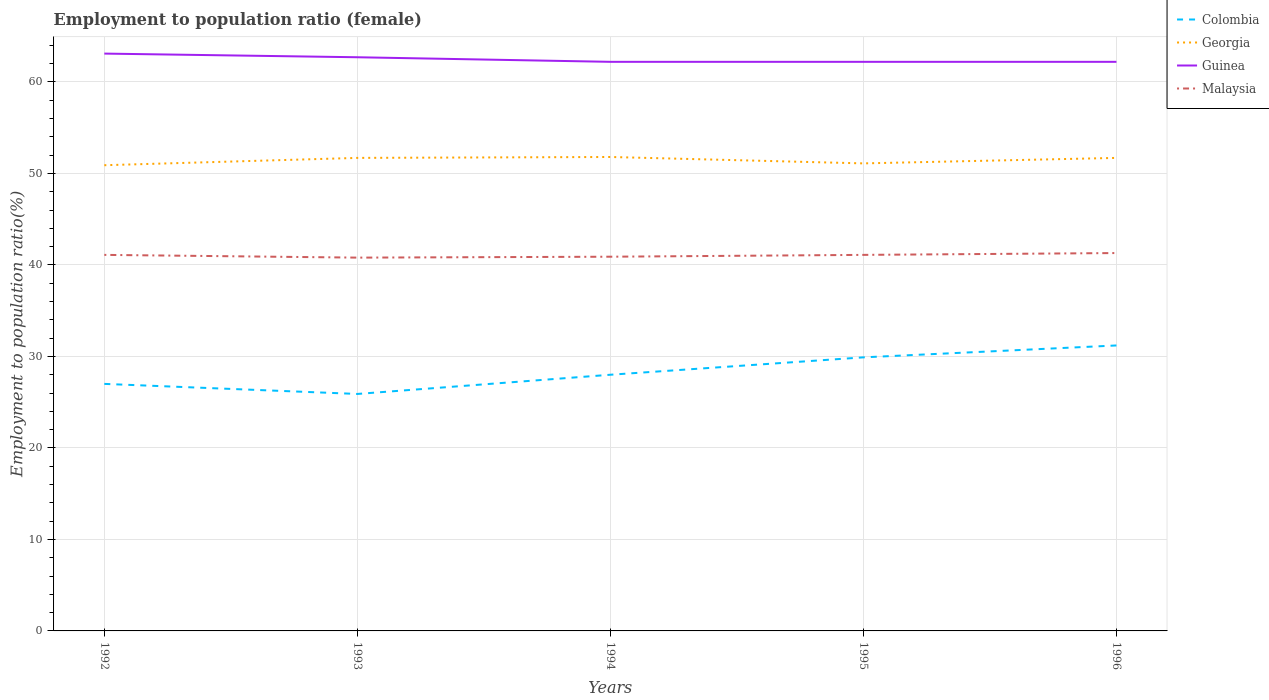How many different coloured lines are there?
Your answer should be very brief. 4. Does the line corresponding to Guinea intersect with the line corresponding to Georgia?
Ensure brevity in your answer.  No. Across all years, what is the maximum employment to population ratio in Malaysia?
Make the answer very short. 40.8. What is the difference between the highest and the second highest employment to population ratio in Georgia?
Make the answer very short. 0.9. What is the difference between the highest and the lowest employment to population ratio in Malaysia?
Provide a short and direct response. 3. Is the employment to population ratio in Georgia strictly greater than the employment to population ratio in Guinea over the years?
Offer a very short reply. Yes. How many lines are there?
Offer a very short reply. 4. Does the graph contain any zero values?
Ensure brevity in your answer.  No. How are the legend labels stacked?
Offer a terse response. Vertical. What is the title of the graph?
Your answer should be compact. Employment to population ratio (female). Does "Kuwait" appear as one of the legend labels in the graph?
Make the answer very short. No. What is the label or title of the X-axis?
Provide a succinct answer. Years. What is the label or title of the Y-axis?
Provide a short and direct response. Employment to population ratio(%). What is the Employment to population ratio(%) in Colombia in 1992?
Provide a succinct answer. 27. What is the Employment to population ratio(%) in Georgia in 1992?
Give a very brief answer. 50.9. What is the Employment to population ratio(%) of Guinea in 1992?
Give a very brief answer. 63.1. What is the Employment to population ratio(%) in Malaysia in 1992?
Provide a short and direct response. 41.1. What is the Employment to population ratio(%) of Colombia in 1993?
Your answer should be very brief. 25.9. What is the Employment to population ratio(%) in Georgia in 1993?
Your answer should be very brief. 51.7. What is the Employment to population ratio(%) in Guinea in 1993?
Give a very brief answer. 62.7. What is the Employment to population ratio(%) in Malaysia in 1993?
Ensure brevity in your answer.  40.8. What is the Employment to population ratio(%) in Colombia in 1994?
Your response must be concise. 28. What is the Employment to population ratio(%) in Georgia in 1994?
Your answer should be compact. 51.8. What is the Employment to population ratio(%) of Guinea in 1994?
Offer a terse response. 62.2. What is the Employment to population ratio(%) in Malaysia in 1994?
Your answer should be very brief. 40.9. What is the Employment to population ratio(%) of Colombia in 1995?
Make the answer very short. 29.9. What is the Employment to population ratio(%) in Georgia in 1995?
Offer a terse response. 51.1. What is the Employment to population ratio(%) of Guinea in 1995?
Provide a short and direct response. 62.2. What is the Employment to population ratio(%) in Malaysia in 1995?
Offer a terse response. 41.1. What is the Employment to population ratio(%) of Colombia in 1996?
Provide a succinct answer. 31.2. What is the Employment to population ratio(%) in Georgia in 1996?
Provide a short and direct response. 51.7. What is the Employment to population ratio(%) of Guinea in 1996?
Offer a terse response. 62.2. What is the Employment to population ratio(%) of Malaysia in 1996?
Provide a succinct answer. 41.3. Across all years, what is the maximum Employment to population ratio(%) of Colombia?
Offer a terse response. 31.2. Across all years, what is the maximum Employment to population ratio(%) in Georgia?
Ensure brevity in your answer.  51.8. Across all years, what is the maximum Employment to population ratio(%) of Guinea?
Provide a short and direct response. 63.1. Across all years, what is the maximum Employment to population ratio(%) in Malaysia?
Provide a short and direct response. 41.3. Across all years, what is the minimum Employment to population ratio(%) of Colombia?
Ensure brevity in your answer.  25.9. Across all years, what is the minimum Employment to population ratio(%) of Georgia?
Ensure brevity in your answer.  50.9. Across all years, what is the minimum Employment to population ratio(%) in Guinea?
Offer a terse response. 62.2. Across all years, what is the minimum Employment to population ratio(%) in Malaysia?
Give a very brief answer. 40.8. What is the total Employment to population ratio(%) of Colombia in the graph?
Your response must be concise. 142. What is the total Employment to population ratio(%) in Georgia in the graph?
Your answer should be compact. 257.2. What is the total Employment to population ratio(%) in Guinea in the graph?
Your response must be concise. 312.4. What is the total Employment to population ratio(%) of Malaysia in the graph?
Keep it short and to the point. 205.2. What is the difference between the Employment to population ratio(%) of Colombia in 1992 and that in 1993?
Your answer should be very brief. 1.1. What is the difference between the Employment to population ratio(%) in Georgia in 1992 and that in 1993?
Keep it short and to the point. -0.8. What is the difference between the Employment to population ratio(%) of Malaysia in 1992 and that in 1993?
Keep it short and to the point. 0.3. What is the difference between the Employment to population ratio(%) of Colombia in 1992 and that in 1994?
Provide a succinct answer. -1. What is the difference between the Employment to population ratio(%) of Georgia in 1992 and that in 1994?
Your response must be concise. -0.9. What is the difference between the Employment to population ratio(%) of Georgia in 1992 and that in 1995?
Ensure brevity in your answer.  -0.2. What is the difference between the Employment to population ratio(%) in Guinea in 1992 and that in 1995?
Offer a terse response. 0.9. What is the difference between the Employment to population ratio(%) in Georgia in 1992 and that in 1996?
Offer a terse response. -0.8. What is the difference between the Employment to population ratio(%) in Colombia in 1993 and that in 1994?
Your response must be concise. -2.1. What is the difference between the Employment to population ratio(%) in Guinea in 1993 and that in 1995?
Give a very brief answer. 0.5. What is the difference between the Employment to population ratio(%) in Malaysia in 1993 and that in 1995?
Provide a succinct answer. -0.3. What is the difference between the Employment to population ratio(%) of Colombia in 1994 and that in 1995?
Make the answer very short. -1.9. What is the difference between the Employment to population ratio(%) of Georgia in 1994 and that in 1995?
Offer a very short reply. 0.7. What is the difference between the Employment to population ratio(%) in Colombia in 1994 and that in 1996?
Offer a terse response. -3.2. What is the difference between the Employment to population ratio(%) in Georgia in 1994 and that in 1996?
Your response must be concise. 0.1. What is the difference between the Employment to population ratio(%) in Guinea in 1994 and that in 1996?
Give a very brief answer. 0. What is the difference between the Employment to population ratio(%) of Malaysia in 1994 and that in 1996?
Your answer should be very brief. -0.4. What is the difference between the Employment to population ratio(%) of Georgia in 1995 and that in 1996?
Your response must be concise. -0.6. What is the difference between the Employment to population ratio(%) in Malaysia in 1995 and that in 1996?
Give a very brief answer. -0.2. What is the difference between the Employment to population ratio(%) of Colombia in 1992 and the Employment to population ratio(%) of Georgia in 1993?
Offer a terse response. -24.7. What is the difference between the Employment to population ratio(%) of Colombia in 1992 and the Employment to population ratio(%) of Guinea in 1993?
Your answer should be compact. -35.7. What is the difference between the Employment to population ratio(%) of Colombia in 1992 and the Employment to population ratio(%) of Malaysia in 1993?
Ensure brevity in your answer.  -13.8. What is the difference between the Employment to population ratio(%) in Georgia in 1992 and the Employment to population ratio(%) in Guinea in 1993?
Your answer should be very brief. -11.8. What is the difference between the Employment to population ratio(%) in Guinea in 1992 and the Employment to population ratio(%) in Malaysia in 1993?
Your response must be concise. 22.3. What is the difference between the Employment to population ratio(%) in Colombia in 1992 and the Employment to population ratio(%) in Georgia in 1994?
Provide a short and direct response. -24.8. What is the difference between the Employment to population ratio(%) of Colombia in 1992 and the Employment to population ratio(%) of Guinea in 1994?
Provide a short and direct response. -35.2. What is the difference between the Employment to population ratio(%) in Colombia in 1992 and the Employment to population ratio(%) in Malaysia in 1994?
Give a very brief answer. -13.9. What is the difference between the Employment to population ratio(%) of Georgia in 1992 and the Employment to population ratio(%) of Guinea in 1994?
Offer a very short reply. -11.3. What is the difference between the Employment to population ratio(%) in Georgia in 1992 and the Employment to population ratio(%) in Malaysia in 1994?
Your answer should be compact. 10. What is the difference between the Employment to population ratio(%) in Guinea in 1992 and the Employment to population ratio(%) in Malaysia in 1994?
Your answer should be very brief. 22.2. What is the difference between the Employment to population ratio(%) in Colombia in 1992 and the Employment to population ratio(%) in Georgia in 1995?
Offer a terse response. -24.1. What is the difference between the Employment to population ratio(%) in Colombia in 1992 and the Employment to population ratio(%) in Guinea in 1995?
Offer a very short reply. -35.2. What is the difference between the Employment to population ratio(%) of Colombia in 1992 and the Employment to population ratio(%) of Malaysia in 1995?
Ensure brevity in your answer.  -14.1. What is the difference between the Employment to population ratio(%) of Georgia in 1992 and the Employment to population ratio(%) of Guinea in 1995?
Offer a very short reply. -11.3. What is the difference between the Employment to population ratio(%) of Georgia in 1992 and the Employment to population ratio(%) of Malaysia in 1995?
Keep it short and to the point. 9.8. What is the difference between the Employment to population ratio(%) of Guinea in 1992 and the Employment to population ratio(%) of Malaysia in 1995?
Make the answer very short. 22. What is the difference between the Employment to population ratio(%) in Colombia in 1992 and the Employment to population ratio(%) in Georgia in 1996?
Offer a terse response. -24.7. What is the difference between the Employment to population ratio(%) of Colombia in 1992 and the Employment to population ratio(%) of Guinea in 1996?
Give a very brief answer. -35.2. What is the difference between the Employment to population ratio(%) in Colombia in 1992 and the Employment to population ratio(%) in Malaysia in 1996?
Your answer should be compact. -14.3. What is the difference between the Employment to population ratio(%) in Georgia in 1992 and the Employment to population ratio(%) in Guinea in 1996?
Provide a short and direct response. -11.3. What is the difference between the Employment to population ratio(%) of Guinea in 1992 and the Employment to population ratio(%) of Malaysia in 1996?
Your answer should be very brief. 21.8. What is the difference between the Employment to population ratio(%) in Colombia in 1993 and the Employment to population ratio(%) in Georgia in 1994?
Your answer should be compact. -25.9. What is the difference between the Employment to population ratio(%) in Colombia in 1993 and the Employment to population ratio(%) in Guinea in 1994?
Offer a terse response. -36.3. What is the difference between the Employment to population ratio(%) of Georgia in 1993 and the Employment to population ratio(%) of Malaysia in 1994?
Provide a short and direct response. 10.8. What is the difference between the Employment to population ratio(%) of Guinea in 1993 and the Employment to population ratio(%) of Malaysia in 1994?
Keep it short and to the point. 21.8. What is the difference between the Employment to population ratio(%) of Colombia in 1993 and the Employment to population ratio(%) of Georgia in 1995?
Your answer should be compact. -25.2. What is the difference between the Employment to population ratio(%) in Colombia in 1993 and the Employment to population ratio(%) in Guinea in 1995?
Ensure brevity in your answer.  -36.3. What is the difference between the Employment to population ratio(%) in Colombia in 1993 and the Employment to population ratio(%) in Malaysia in 1995?
Provide a short and direct response. -15.2. What is the difference between the Employment to population ratio(%) in Georgia in 1993 and the Employment to population ratio(%) in Guinea in 1995?
Offer a very short reply. -10.5. What is the difference between the Employment to population ratio(%) in Guinea in 1993 and the Employment to population ratio(%) in Malaysia in 1995?
Offer a terse response. 21.6. What is the difference between the Employment to population ratio(%) in Colombia in 1993 and the Employment to population ratio(%) in Georgia in 1996?
Your response must be concise. -25.8. What is the difference between the Employment to population ratio(%) of Colombia in 1993 and the Employment to population ratio(%) of Guinea in 1996?
Make the answer very short. -36.3. What is the difference between the Employment to population ratio(%) of Colombia in 1993 and the Employment to population ratio(%) of Malaysia in 1996?
Keep it short and to the point. -15.4. What is the difference between the Employment to population ratio(%) in Georgia in 1993 and the Employment to population ratio(%) in Guinea in 1996?
Give a very brief answer. -10.5. What is the difference between the Employment to population ratio(%) of Georgia in 1993 and the Employment to population ratio(%) of Malaysia in 1996?
Keep it short and to the point. 10.4. What is the difference between the Employment to population ratio(%) of Guinea in 1993 and the Employment to population ratio(%) of Malaysia in 1996?
Offer a terse response. 21.4. What is the difference between the Employment to population ratio(%) of Colombia in 1994 and the Employment to population ratio(%) of Georgia in 1995?
Keep it short and to the point. -23.1. What is the difference between the Employment to population ratio(%) of Colombia in 1994 and the Employment to population ratio(%) of Guinea in 1995?
Ensure brevity in your answer.  -34.2. What is the difference between the Employment to population ratio(%) of Georgia in 1994 and the Employment to population ratio(%) of Guinea in 1995?
Ensure brevity in your answer.  -10.4. What is the difference between the Employment to population ratio(%) of Georgia in 1994 and the Employment to population ratio(%) of Malaysia in 1995?
Your response must be concise. 10.7. What is the difference between the Employment to population ratio(%) in Guinea in 1994 and the Employment to population ratio(%) in Malaysia in 1995?
Give a very brief answer. 21.1. What is the difference between the Employment to population ratio(%) in Colombia in 1994 and the Employment to population ratio(%) in Georgia in 1996?
Offer a terse response. -23.7. What is the difference between the Employment to population ratio(%) in Colombia in 1994 and the Employment to population ratio(%) in Guinea in 1996?
Your answer should be very brief. -34.2. What is the difference between the Employment to population ratio(%) in Georgia in 1994 and the Employment to population ratio(%) in Guinea in 1996?
Ensure brevity in your answer.  -10.4. What is the difference between the Employment to population ratio(%) in Georgia in 1994 and the Employment to population ratio(%) in Malaysia in 1996?
Provide a short and direct response. 10.5. What is the difference between the Employment to population ratio(%) in Guinea in 1994 and the Employment to population ratio(%) in Malaysia in 1996?
Make the answer very short. 20.9. What is the difference between the Employment to population ratio(%) in Colombia in 1995 and the Employment to population ratio(%) in Georgia in 1996?
Make the answer very short. -21.8. What is the difference between the Employment to population ratio(%) in Colombia in 1995 and the Employment to population ratio(%) in Guinea in 1996?
Your response must be concise. -32.3. What is the difference between the Employment to population ratio(%) of Georgia in 1995 and the Employment to population ratio(%) of Guinea in 1996?
Provide a succinct answer. -11.1. What is the difference between the Employment to population ratio(%) in Guinea in 1995 and the Employment to population ratio(%) in Malaysia in 1996?
Provide a succinct answer. 20.9. What is the average Employment to population ratio(%) in Colombia per year?
Provide a succinct answer. 28.4. What is the average Employment to population ratio(%) in Georgia per year?
Make the answer very short. 51.44. What is the average Employment to population ratio(%) in Guinea per year?
Give a very brief answer. 62.48. What is the average Employment to population ratio(%) of Malaysia per year?
Your answer should be compact. 41.04. In the year 1992, what is the difference between the Employment to population ratio(%) of Colombia and Employment to population ratio(%) of Georgia?
Your answer should be very brief. -23.9. In the year 1992, what is the difference between the Employment to population ratio(%) of Colombia and Employment to population ratio(%) of Guinea?
Provide a short and direct response. -36.1. In the year 1992, what is the difference between the Employment to population ratio(%) of Colombia and Employment to population ratio(%) of Malaysia?
Your response must be concise. -14.1. In the year 1992, what is the difference between the Employment to population ratio(%) of Georgia and Employment to population ratio(%) of Guinea?
Your response must be concise. -12.2. In the year 1992, what is the difference between the Employment to population ratio(%) of Georgia and Employment to population ratio(%) of Malaysia?
Ensure brevity in your answer.  9.8. In the year 1992, what is the difference between the Employment to population ratio(%) in Guinea and Employment to population ratio(%) in Malaysia?
Offer a very short reply. 22. In the year 1993, what is the difference between the Employment to population ratio(%) of Colombia and Employment to population ratio(%) of Georgia?
Your answer should be very brief. -25.8. In the year 1993, what is the difference between the Employment to population ratio(%) of Colombia and Employment to population ratio(%) of Guinea?
Provide a succinct answer. -36.8. In the year 1993, what is the difference between the Employment to population ratio(%) in Colombia and Employment to population ratio(%) in Malaysia?
Give a very brief answer. -14.9. In the year 1993, what is the difference between the Employment to population ratio(%) of Georgia and Employment to population ratio(%) of Malaysia?
Make the answer very short. 10.9. In the year 1993, what is the difference between the Employment to population ratio(%) of Guinea and Employment to population ratio(%) of Malaysia?
Provide a short and direct response. 21.9. In the year 1994, what is the difference between the Employment to population ratio(%) of Colombia and Employment to population ratio(%) of Georgia?
Make the answer very short. -23.8. In the year 1994, what is the difference between the Employment to population ratio(%) in Colombia and Employment to population ratio(%) in Guinea?
Ensure brevity in your answer.  -34.2. In the year 1994, what is the difference between the Employment to population ratio(%) in Georgia and Employment to population ratio(%) in Malaysia?
Offer a very short reply. 10.9. In the year 1994, what is the difference between the Employment to population ratio(%) of Guinea and Employment to population ratio(%) of Malaysia?
Your answer should be compact. 21.3. In the year 1995, what is the difference between the Employment to population ratio(%) in Colombia and Employment to population ratio(%) in Georgia?
Your answer should be compact. -21.2. In the year 1995, what is the difference between the Employment to population ratio(%) in Colombia and Employment to population ratio(%) in Guinea?
Provide a succinct answer. -32.3. In the year 1995, what is the difference between the Employment to population ratio(%) of Georgia and Employment to population ratio(%) of Malaysia?
Give a very brief answer. 10. In the year 1995, what is the difference between the Employment to population ratio(%) in Guinea and Employment to population ratio(%) in Malaysia?
Keep it short and to the point. 21.1. In the year 1996, what is the difference between the Employment to population ratio(%) in Colombia and Employment to population ratio(%) in Georgia?
Your answer should be very brief. -20.5. In the year 1996, what is the difference between the Employment to population ratio(%) of Colombia and Employment to population ratio(%) of Guinea?
Your answer should be very brief. -31. In the year 1996, what is the difference between the Employment to population ratio(%) in Colombia and Employment to population ratio(%) in Malaysia?
Offer a terse response. -10.1. In the year 1996, what is the difference between the Employment to population ratio(%) in Georgia and Employment to population ratio(%) in Guinea?
Provide a succinct answer. -10.5. In the year 1996, what is the difference between the Employment to population ratio(%) of Guinea and Employment to population ratio(%) of Malaysia?
Offer a very short reply. 20.9. What is the ratio of the Employment to population ratio(%) of Colombia in 1992 to that in 1993?
Your answer should be very brief. 1.04. What is the ratio of the Employment to population ratio(%) in Georgia in 1992 to that in 1993?
Offer a terse response. 0.98. What is the ratio of the Employment to population ratio(%) of Guinea in 1992 to that in 1993?
Provide a short and direct response. 1.01. What is the ratio of the Employment to population ratio(%) of Malaysia in 1992 to that in 1993?
Keep it short and to the point. 1.01. What is the ratio of the Employment to population ratio(%) in Colombia in 1992 to that in 1994?
Offer a terse response. 0.96. What is the ratio of the Employment to population ratio(%) of Georgia in 1992 to that in 1994?
Make the answer very short. 0.98. What is the ratio of the Employment to population ratio(%) in Guinea in 1992 to that in 1994?
Offer a very short reply. 1.01. What is the ratio of the Employment to population ratio(%) of Malaysia in 1992 to that in 1994?
Your answer should be very brief. 1. What is the ratio of the Employment to population ratio(%) in Colombia in 1992 to that in 1995?
Give a very brief answer. 0.9. What is the ratio of the Employment to population ratio(%) of Georgia in 1992 to that in 1995?
Provide a short and direct response. 1. What is the ratio of the Employment to population ratio(%) in Guinea in 1992 to that in 1995?
Make the answer very short. 1.01. What is the ratio of the Employment to population ratio(%) in Malaysia in 1992 to that in 1995?
Give a very brief answer. 1. What is the ratio of the Employment to population ratio(%) of Colombia in 1992 to that in 1996?
Offer a terse response. 0.87. What is the ratio of the Employment to population ratio(%) of Georgia in 1992 to that in 1996?
Keep it short and to the point. 0.98. What is the ratio of the Employment to population ratio(%) of Guinea in 1992 to that in 1996?
Keep it short and to the point. 1.01. What is the ratio of the Employment to population ratio(%) in Colombia in 1993 to that in 1994?
Give a very brief answer. 0.93. What is the ratio of the Employment to population ratio(%) of Guinea in 1993 to that in 1994?
Keep it short and to the point. 1.01. What is the ratio of the Employment to population ratio(%) of Colombia in 1993 to that in 1995?
Provide a succinct answer. 0.87. What is the ratio of the Employment to population ratio(%) in Georgia in 1993 to that in 1995?
Offer a terse response. 1.01. What is the ratio of the Employment to population ratio(%) of Guinea in 1993 to that in 1995?
Offer a terse response. 1.01. What is the ratio of the Employment to population ratio(%) in Colombia in 1993 to that in 1996?
Your answer should be compact. 0.83. What is the ratio of the Employment to population ratio(%) of Malaysia in 1993 to that in 1996?
Make the answer very short. 0.99. What is the ratio of the Employment to population ratio(%) of Colombia in 1994 to that in 1995?
Your answer should be compact. 0.94. What is the ratio of the Employment to population ratio(%) of Georgia in 1994 to that in 1995?
Provide a succinct answer. 1.01. What is the ratio of the Employment to population ratio(%) of Guinea in 1994 to that in 1995?
Your answer should be very brief. 1. What is the ratio of the Employment to population ratio(%) of Malaysia in 1994 to that in 1995?
Ensure brevity in your answer.  1. What is the ratio of the Employment to population ratio(%) of Colombia in 1994 to that in 1996?
Your response must be concise. 0.9. What is the ratio of the Employment to population ratio(%) in Georgia in 1994 to that in 1996?
Provide a short and direct response. 1. What is the ratio of the Employment to population ratio(%) of Malaysia in 1994 to that in 1996?
Ensure brevity in your answer.  0.99. What is the ratio of the Employment to population ratio(%) of Georgia in 1995 to that in 1996?
Provide a succinct answer. 0.99. What is the difference between the highest and the second highest Employment to population ratio(%) of Guinea?
Make the answer very short. 0.4. What is the difference between the highest and the lowest Employment to population ratio(%) of Colombia?
Your answer should be compact. 5.3. What is the difference between the highest and the lowest Employment to population ratio(%) of Georgia?
Your answer should be compact. 0.9. What is the difference between the highest and the lowest Employment to population ratio(%) in Guinea?
Your answer should be compact. 0.9. 